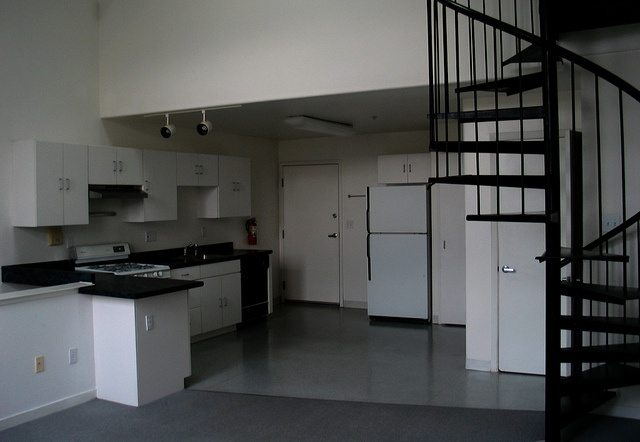Describe the objects in this image and their specific colors. I can see refrigerator in gray and black tones, oven in gray, black, purple, and darkblue tones, and sink in black, darkgray, and gray tones in this image. 